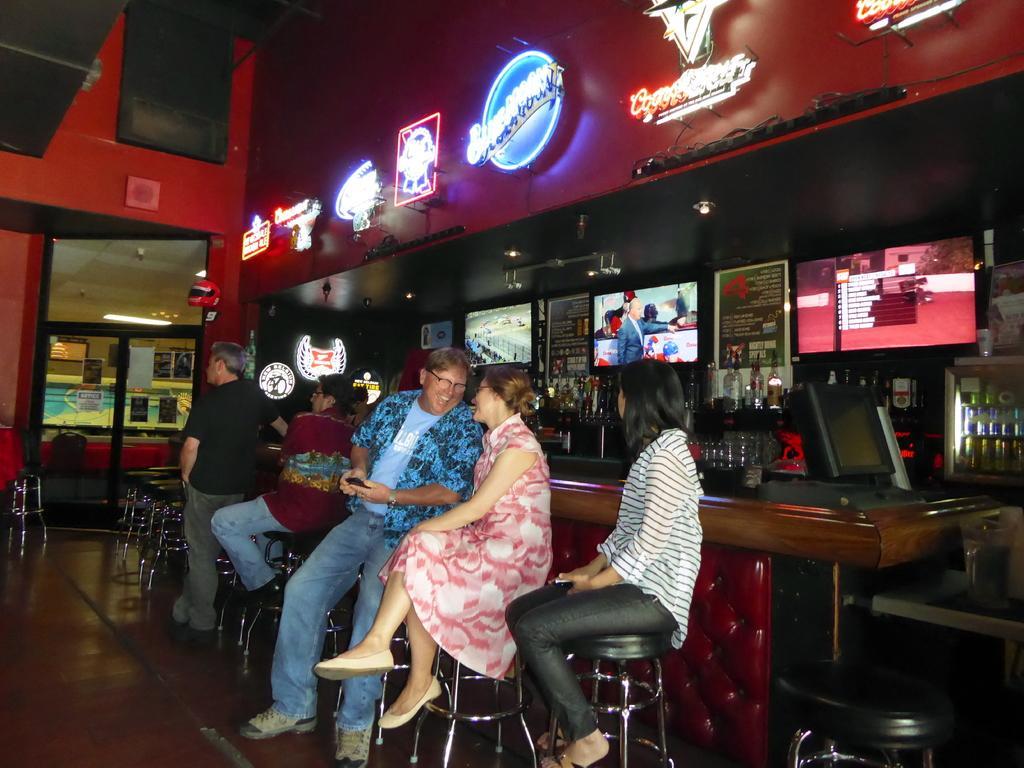In one or two sentences, can you explain what this image depicts? This image consists of few people. It looks like a restaurant. On the right, there is a bar counter. They are sitting on the chairs. At the bottom, there is a floor. In the background, we can see many bottles and a wall. 